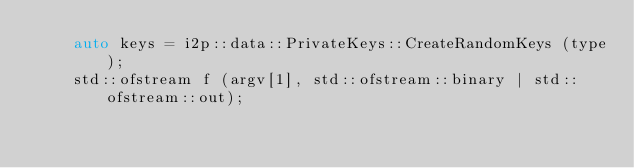Convert code to text. <code><loc_0><loc_0><loc_500><loc_500><_C++_>	auto keys = i2p::data::PrivateKeys::CreateRandomKeys (type);
	std::ofstream f (argv[1], std::ofstream::binary | std::ofstream::out);</code> 